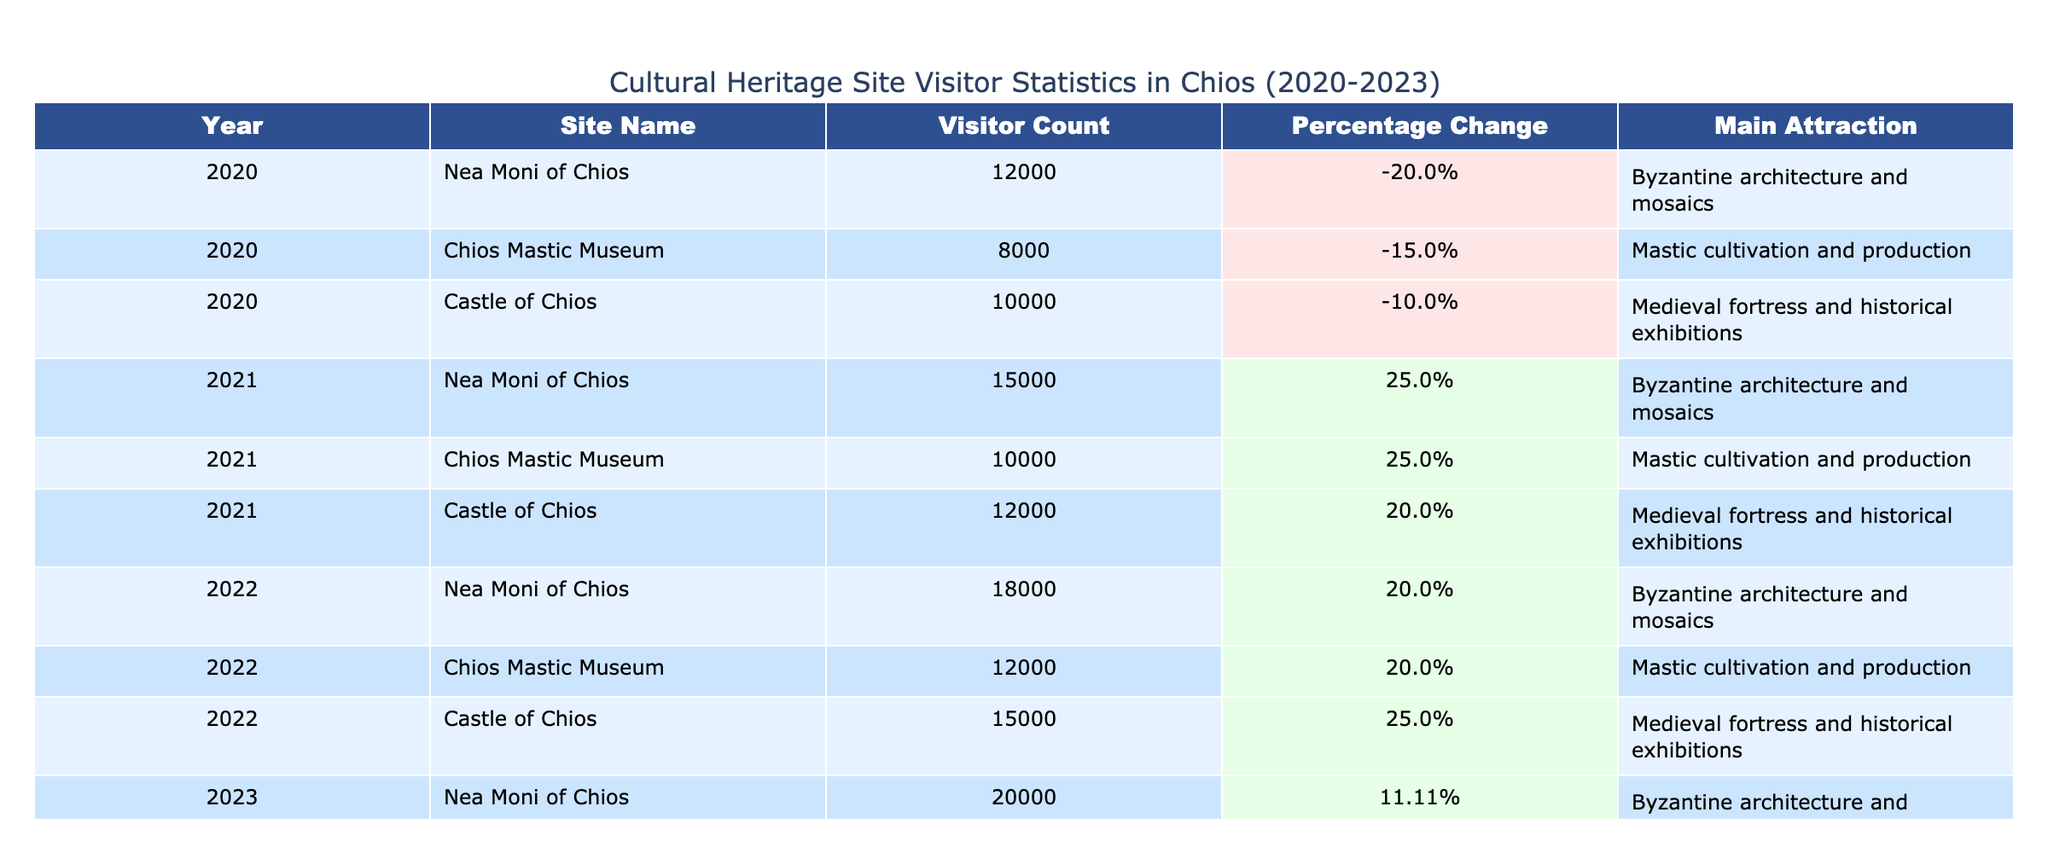What was the visitor count for the Chios Mastic Museum in 2021? The table lists the visitor count for the Chios Mastic Museum in 2021, which is directly provided as 10,000.
Answer: 10,000 Which site had the highest visitor count in 2023? Looking at the table, the highest visitor count in 2023 is for Nea Moni of Chios with a total of 20,000 visitors.
Answer: Nea Moni of Chios What was the percentage change in visitor count for the Castle of Chios from 2020 to 2021? The visitor count for the Castle of Chios was 10,000 in 2020 and increased to 12,000 in 2021. The percentage change is calculated as ((12,000 - 10,000) / 10,000) * 100 = 20%.
Answer: 20% Did the visitor count for the Chios Mastic Museum increase every year from 2020 to 2023? From the table, the visitor counts are 8,000 in 2020, 10,000 in 2021, 12,000 in 2022, and 15,000 in 2023, showing a year-on-year increase, thus confirming the statement is true.
Answer: Yes What is the average visitor count for the Nea Moni of Chios over the four years shown? The visitor counts for Nea Moni of Chios are 12,000 (2020), 15,000 (2021), 18,000 (2022), and 20,000 (2023). Their sum is 12,000 + 15,000 + 18,000 + 20,000 = 65,000. Dividing by the number of years (4) gives an average of 16,250.
Answer: 16,250 Which site had the lowest percentage change in visitor count in 2022? The percentage changes in 2022 were 20% for Nea Moni, 20% for Chios Mastic Museum, and 25% for Castle of Chios. The lowest change is 20%, applying to Nea Moni and Chios Mastic Museum. Since there are no lower percentages, both sites share the lowest increase here.
Answer: Nea Moni of Chios and Chios Mastic Museum How many more visitors did the Castle of Chios have compared to the Chios Mastic Museum in 2022? Looking at 2022, the Castle of Chios had 15,000 visitors, while the Chios Mastic Museum had 12,000 visitors. The difference is 15,000 - 12,000 = 3,000.
Answer: 3,000 Was there any year when the visitor count for Nea Moni of Chios decreased? Observing the table, the visitor counts increased from 12,000 in 2020 to 20,000 in 2023, with no decrease recorded. Therefore, the answer is false.
Answer: No 